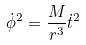Convert formula to latex. <formula><loc_0><loc_0><loc_500><loc_500>\dot { \phi } ^ { 2 } = \frac { M } { r ^ { 3 } } \dot { t } ^ { 2 }</formula> 